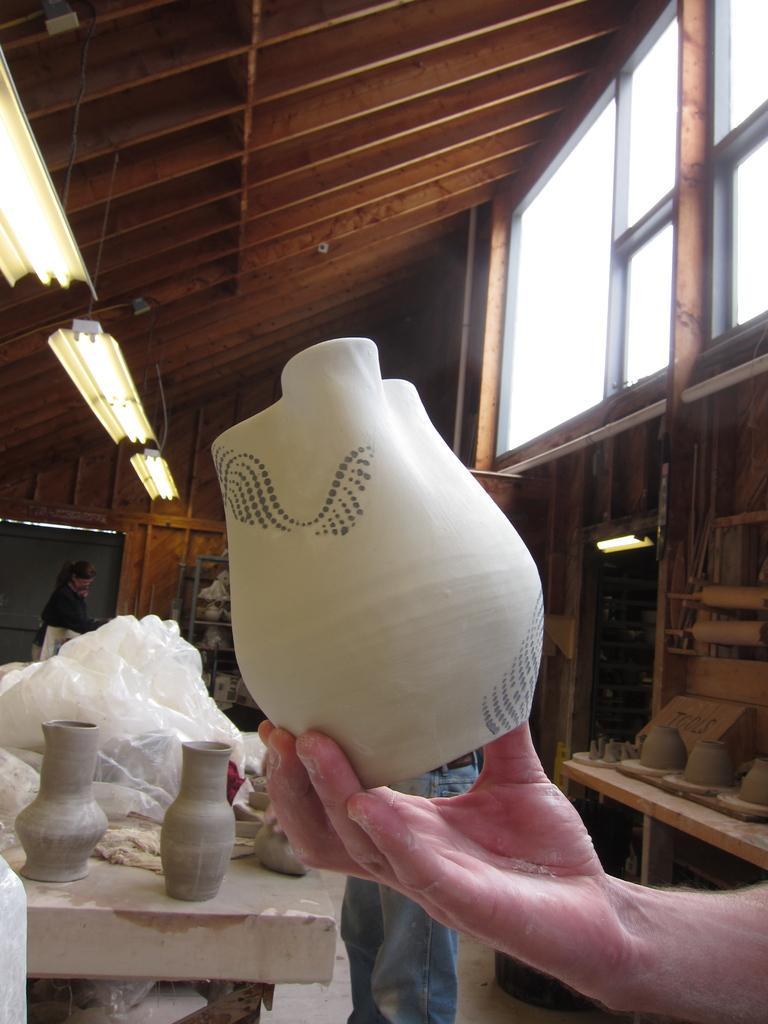How would you summarize this image in a sentence or two? In this image I can see a hand of a person is holding a white colour pot. In background I can see number of pots, plastic, tube lights and I can also see few people. 